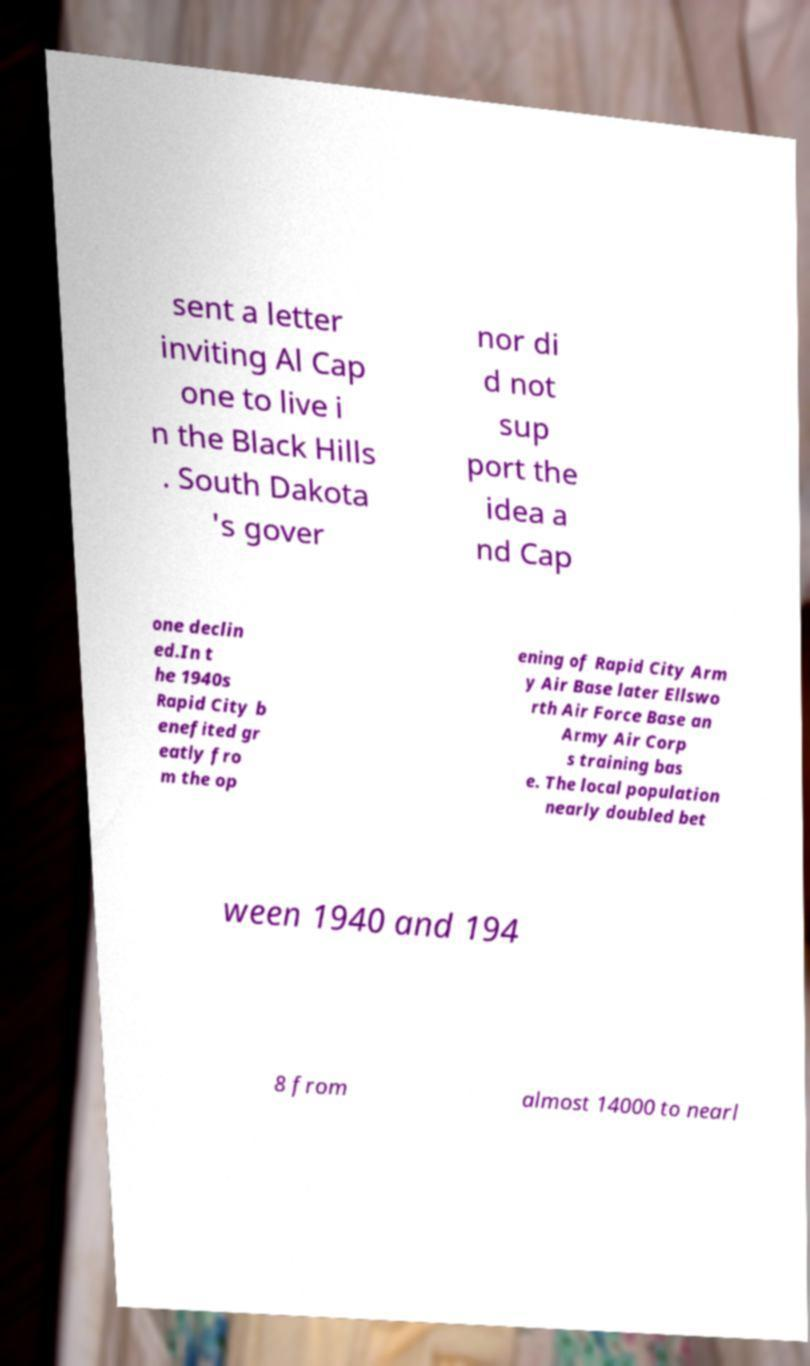I need the written content from this picture converted into text. Can you do that? sent a letter inviting Al Cap one to live i n the Black Hills . South Dakota 's gover nor di d not sup port the idea a nd Cap one declin ed.In t he 1940s Rapid City b enefited gr eatly fro m the op ening of Rapid City Arm y Air Base later Ellswo rth Air Force Base an Army Air Corp s training bas e. The local population nearly doubled bet ween 1940 and 194 8 from almost 14000 to nearl 